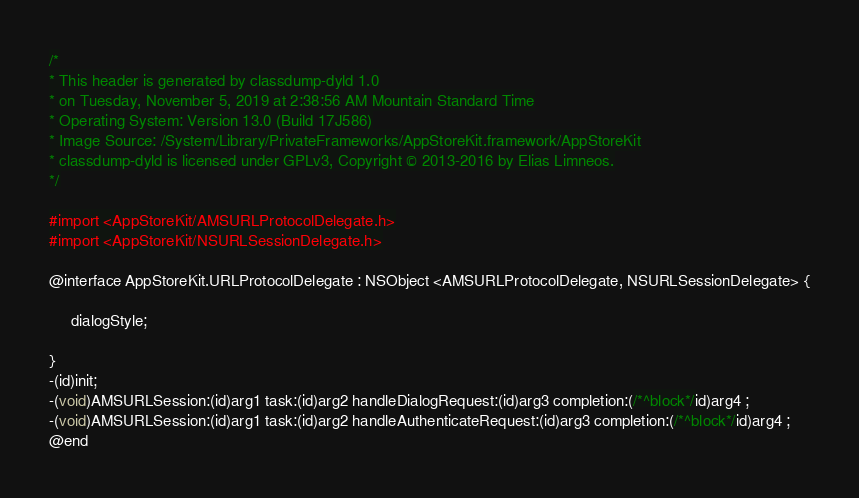<code> <loc_0><loc_0><loc_500><loc_500><_C_>/*
* This header is generated by classdump-dyld 1.0
* on Tuesday, November 5, 2019 at 2:38:56 AM Mountain Standard Time
* Operating System: Version 13.0 (Build 17J586)
* Image Source: /System/Library/PrivateFrameworks/AppStoreKit.framework/AppStoreKit
* classdump-dyld is licensed under GPLv3, Copyright © 2013-2016 by Elias Limneos.
*/

#import <AppStoreKit/AMSURLProtocolDelegate.h>
#import <AppStoreKit/NSURLSessionDelegate.h>

@interface AppStoreKit.URLProtocolDelegate : NSObject <AMSURLProtocolDelegate, NSURLSessionDelegate> {

	 dialogStyle;

}
-(id)init;
-(void)AMSURLSession:(id)arg1 task:(id)arg2 handleDialogRequest:(id)arg3 completion:(/*^block*/id)arg4 ;
-(void)AMSURLSession:(id)arg1 task:(id)arg2 handleAuthenticateRequest:(id)arg3 completion:(/*^block*/id)arg4 ;
@end

</code> 